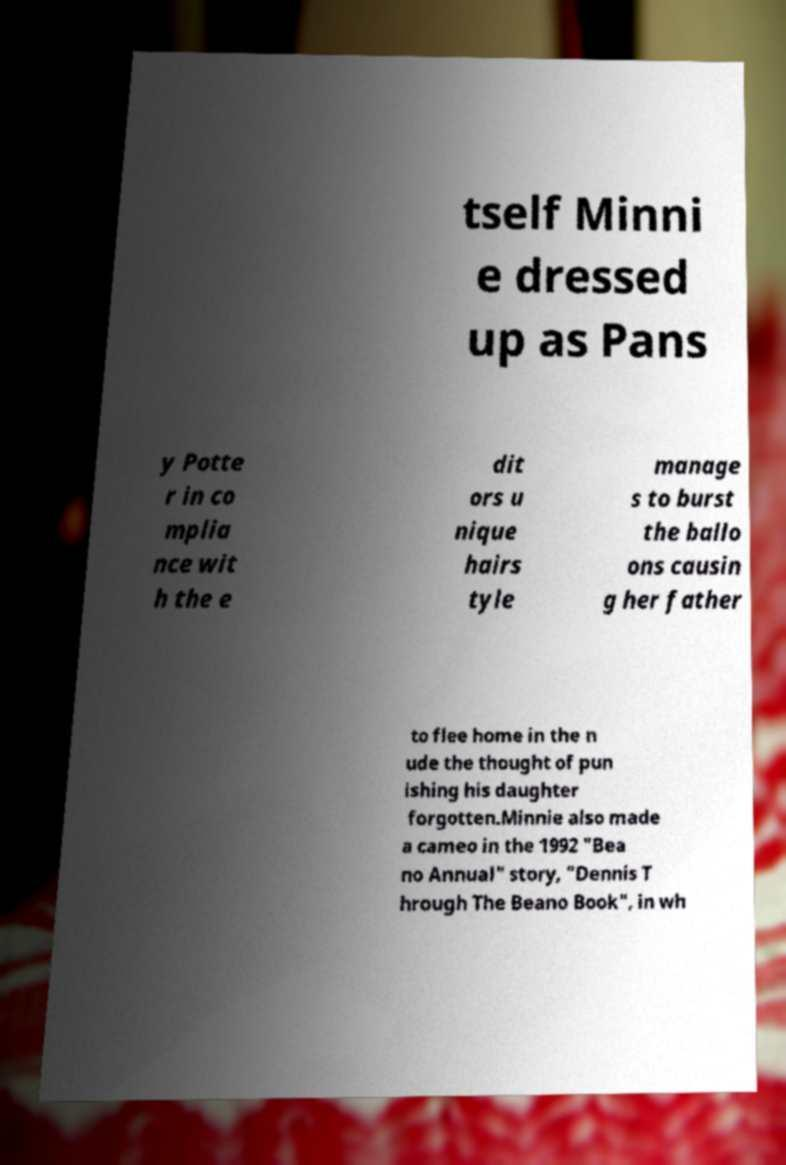For documentation purposes, I need the text within this image transcribed. Could you provide that? tself Minni e dressed up as Pans y Potte r in co mplia nce wit h the e dit ors u nique hairs tyle manage s to burst the ballo ons causin g her father to flee home in the n ude the thought of pun ishing his daughter forgotten.Minnie also made a cameo in the 1992 "Bea no Annual" story, "Dennis T hrough The Beano Book", in wh 